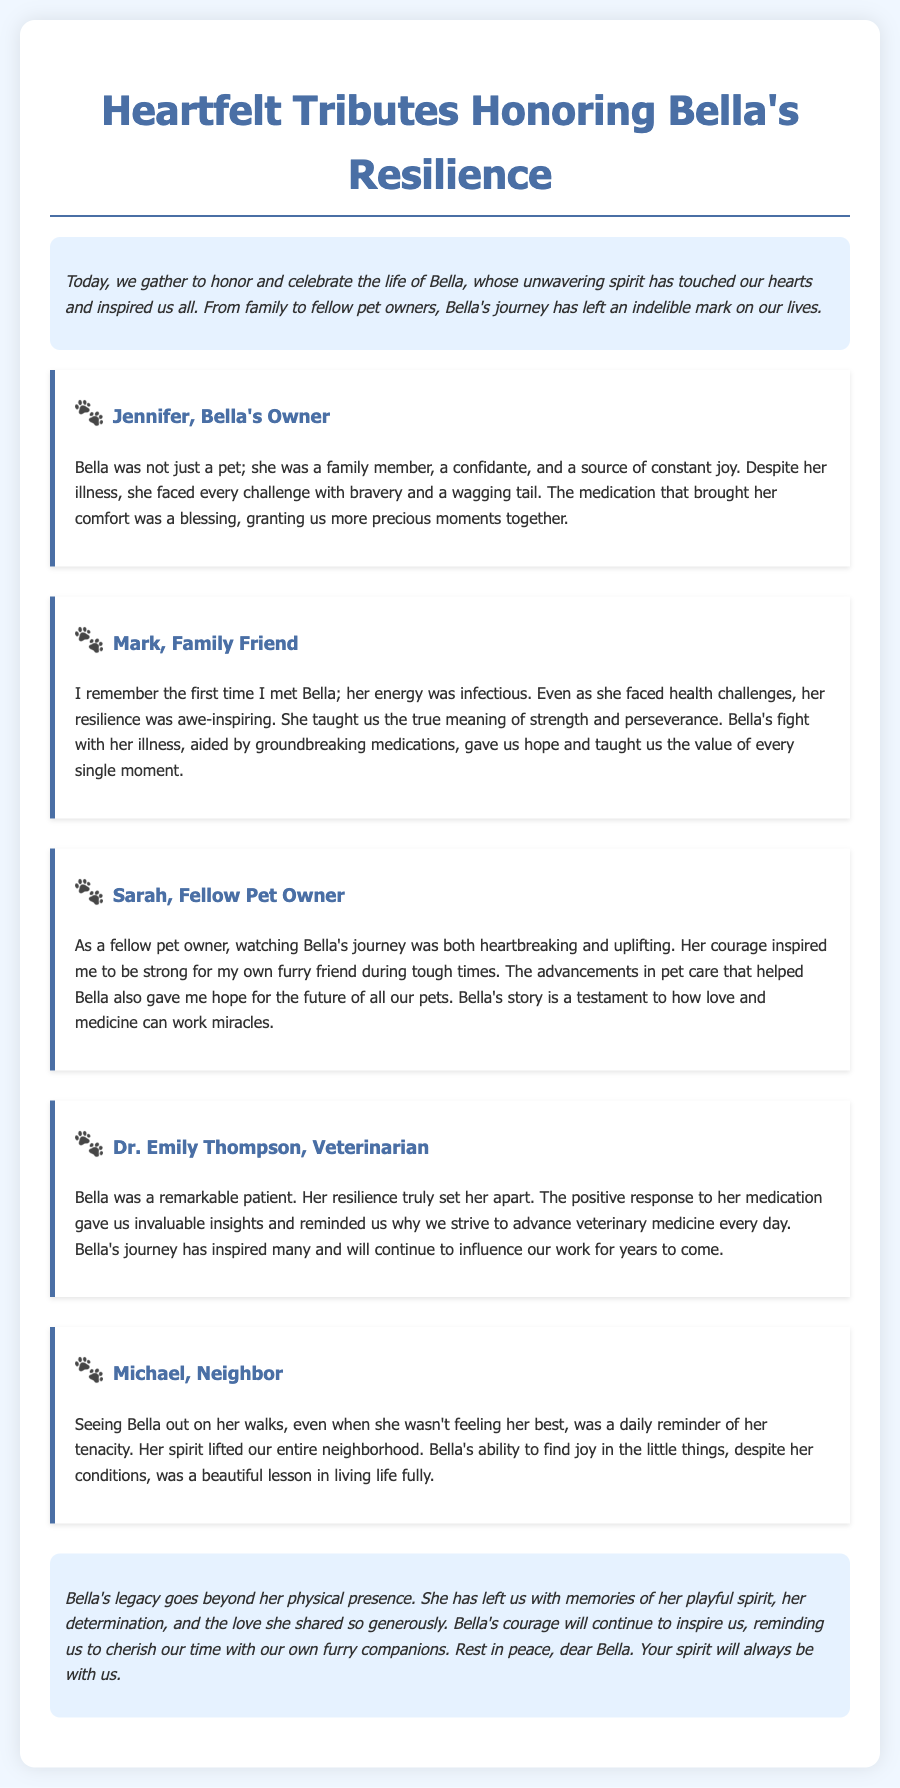What is the title of the document? The title is prominently displayed at the top of the document, indicating the purpose of the eulogy.
Answer: Heartfelt Tributes Honoring Bella's Resilience Who is Bella's owner? The document identifies Bella's owner, who provides a personal tribute in the eulogy.
Answer: Jennifer What animal is the subject of the eulogy? The eulogy centers around a beloved pet, specifically mentioned several times throughout the document.
Answer: Bella How many tributes are included in the document? The number of individual tributes from different people can be counted in the tribute section of the document.
Answer: Five What profession does Dr. Emily Thompson hold? The document describes Dr. Emily's profession, indicating her relationship to Bella.
Answer: Veterinarian How did Bella's medications impact the tributes? The eulogy reflects on how Bella's medications positively affected her quality of life and the lives of those around her.
Answer: Provided comfort Which pet owner shared feelings of inspiration from Bella's courage? The eulogy includes a tribute from another pet owner who expresses the influence of Bella's journey.
Answer: Sarah What is a key theme emphasized throughout the eulogy? The document consistently highlights a particular theme regarding Bella's impact on those who knew her.
Answer: Resilience What is mentioned about the neighborhood's reaction to Bella? The eulogy describes the broader community's response to Bella's spirit, capturing her influence beyond her family.
Answer: Lifted spirits 